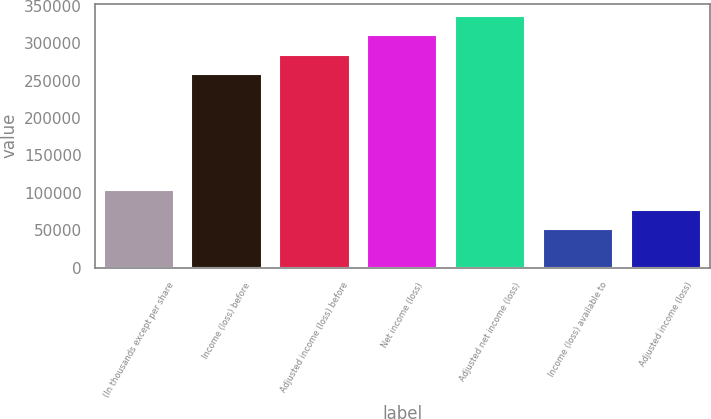<chart> <loc_0><loc_0><loc_500><loc_500><bar_chart><fcel>(In thousands except per share<fcel>Income (loss) before<fcel>Adjusted income (loss) before<fcel>Net income (loss)<fcel>Adjusted net income (loss)<fcel>Income (loss) available to<fcel>Adjusted income (loss)<nl><fcel>103434<fcel>258581<fcel>284439<fcel>310297<fcel>336154<fcel>51718.9<fcel>77576.6<nl></chart> 